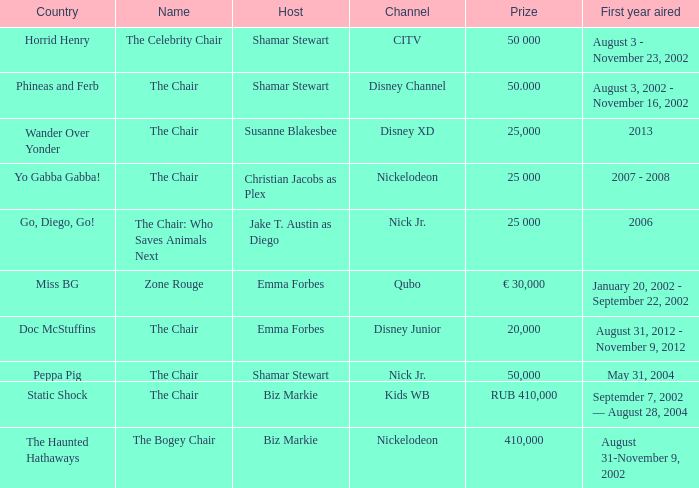What was the first year that had a prize of 50,000? May 31, 2004. Would you be able to parse every entry in this table? {'header': ['Country', 'Name', 'Host', 'Channel', 'Prize', 'First year aired'], 'rows': [['Horrid Henry', 'The Celebrity Chair', 'Shamar Stewart', 'CITV', '50 000', 'August 3 - November 23, 2002'], ['Phineas and Ferb', 'The Chair', 'Shamar Stewart', 'Disney Channel', '50.000', 'August 3, 2002 - November 16, 2002'], ['Wander Over Yonder', 'The Chair', 'Susanne Blakesbee', 'Disney XD', '25,000', '2013'], ['Yo Gabba Gabba!', 'The Chair', 'Christian Jacobs as Plex', 'Nickelodeon', '25 000', '2007 - 2008'], ['Go, Diego, Go!', 'The Chair: Who Saves Animals Next', 'Jake T. Austin as Diego', 'Nick Jr.', '25 000', '2006'], ['Miss BG', 'Zone Rouge', 'Emma Forbes', 'Qubo', '€ 30,000', 'January 20, 2002 - September 22, 2002'], ['Doc McStuffins', 'The Chair', 'Emma Forbes', 'Disney Junior', '20,000', 'August 31, 2012 - November 9, 2012'], ['Peppa Pig', 'The Chair', 'Shamar Stewart', 'Nick Jr.', '50,000', 'May 31, 2004'], ['Static Shock', 'The Chair', 'Biz Markie', 'Kids WB', 'RUB 410,000', 'Septemder 7, 2002 — August 28, 2004'], ['The Haunted Hathaways', 'The Bogey Chair', 'Biz Markie', 'Nickelodeon', '410,000', 'August 31-November 9, 2002']]} 